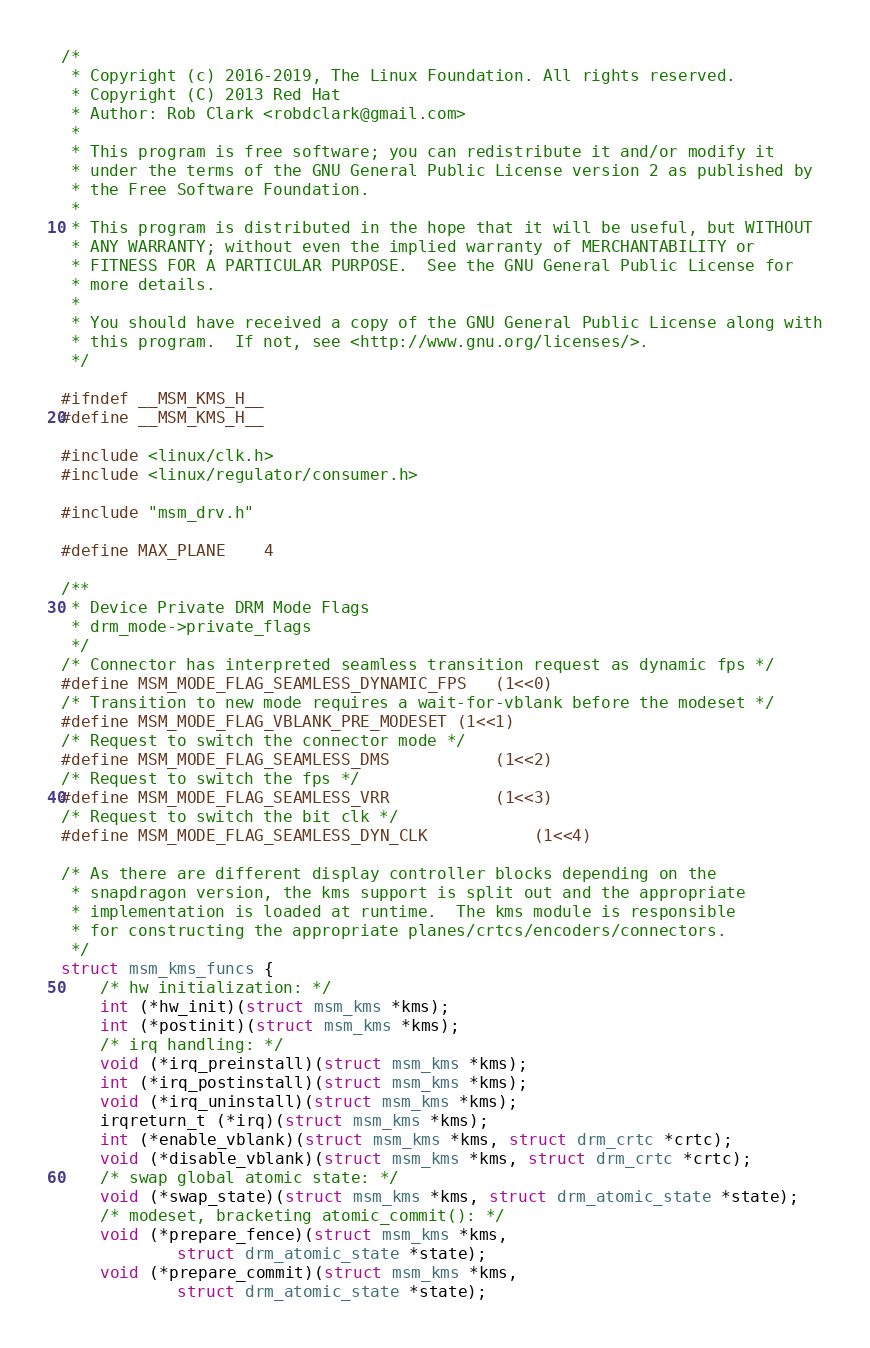<code> <loc_0><loc_0><loc_500><loc_500><_C_>/*
 * Copyright (c) 2016-2019, The Linux Foundation. All rights reserved.
 * Copyright (C) 2013 Red Hat
 * Author: Rob Clark <robdclark@gmail.com>
 *
 * This program is free software; you can redistribute it and/or modify it
 * under the terms of the GNU General Public License version 2 as published by
 * the Free Software Foundation.
 *
 * This program is distributed in the hope that it will be useful, but WITHOUT
 * ANY WARRANTY; without even the implied warranty of MERCHANTABILITY or
 * FITNESS FOR A PARTICULAR PURPOSE.  See the GNU General Public License for
 * more details.
 *
 * You should have received a copy of the GNU General Public License along with
 * this program.  If not, see <http://www.gnu.org/licenses/>.
 */

#ifndef __MSM_KMS_H__
#define __MSM_KMS_H__

#include <linux/clk.h>
#include <linux/regulator/consumer.h>

#include "msm_drv.h"

#define MAX_PLANE	4

/**
 * Device Private DRM Mode Flags
 * drm_mode->private_flags
 */
/* Connector has interpreted seamless transition request as dynamic fps */
#define MSM_MODE_FLAG_SEAMLESS_DYNAMIC_FPS	(1<<0)
/* Transition to new mode requires a wait-for-vblank before the modeset */
#define MSM_MODE_FLAG_VBLANK_PRE_MODESET	(1<<1)
/* Request to switch the connector mode */
#define MSM_MODE_FLAG_SEAMLESS_DMS			(1<<2)
/* Request to switch the fps */
#define MSM_MODE_FLAG_SEAMLESS_VRR			(1<<3)
/* Request to switch the bit clk */
#define MSM_MODE_FLAG_SEAMLESS_DYN_CLK			(1<<4)

/* As there are different display controller blocks depending on the
 * snapdragon version, the kms support is split out and the appropriate
 * implementation is loaded at runtime.  The kms module is responsible
 * for constructing the appropriate planes/crtcs/encoders/connectors.
 */
struct msm_kms_funcs {
	/* hw initialization: */
	int (*hw_init)(struct msm_kms *kms);
	int (*postinit)(struct msm_kms *kms);
	/* irq handling: */
	void (*irq_preinstall)(struct msm_kms *kms);
	int (*irq_postinstall)(struct msm_kms *kms);
	void (*irq_uninstall)(struct msm_kms *kms);
	irqreturn_t (*irq)(struct msm_kms *kms);
	int (*enable_vblank)(struct msm_kms *kms, struct drm_crtc *crtc);
	void (*disable_vblank)(struct msm_kms *kms, struct drm_crtc *crtc);
	/* swap global atomic state: */
	void (*swap_state)(struct msm_kms *kms, struct drm_atomic_state *state);
	/* modeset, bracketing atomic_commit(): */
	void (*prepare_fence)(struct msm_kms *kms,
			struct drm_atomic_state *state);
	void (*prepare_commit)(struct msm_kms *kms,
			struct drm_atomic_state *state);</code> 